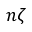<formula> <loc_0><loc_0><loc_500><loc_500>n \zeta</formula> 